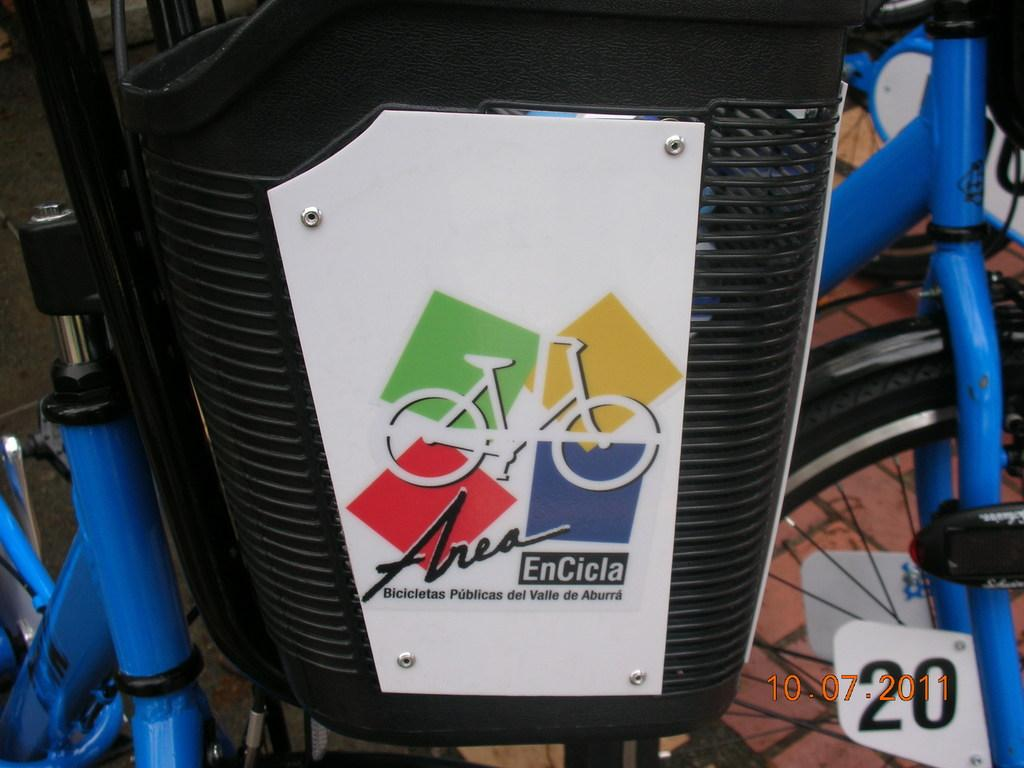What type of vehicles are in the image? There are bicycles in the image. Are there any additional features on the bicycles? Yes, there is a basket on one of the bicycles. What is inside the basket? The basket contains logos. Is there any information about the date in the image? Yes, there is a date visible in the bottom right corner of the image. How many ladybugs can be seen on the bicycles in the image? There are no ladybugs present in the image. What type of hat is the person wearing while riding the bicycle? There is no person or hat visible in the image; it only features bicycles with a basket and logos. 